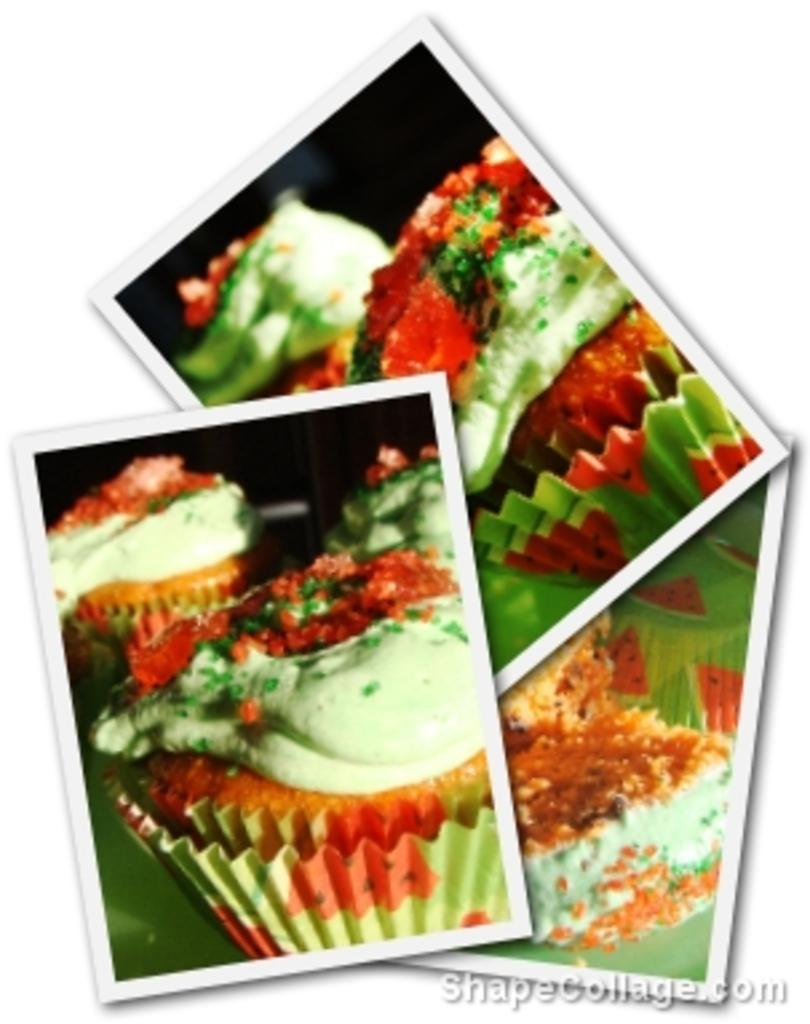What type of images are present in the image? There are photographs in the image. What is depicted in the photographs? The photographs contain food items. Can you describe any additional features of the image? There is a watermark in the bottom right corner of the image. What grade did your aunt receive on her approval of the food items in the image? There is no mention of an aunt or approval in the image, so this question cannot be answered. 